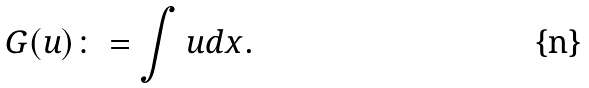Convert formula to latex. <formula><loc_0><loc_0><loc_500><loc_500>G ( u ) \colon = \int u d x .</formula> 